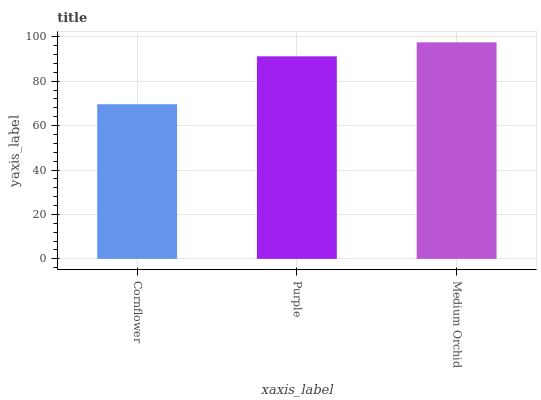Is Purple the minimum?
Answer yes or no. No. Is Purple the maximum?
Answer yes or no. No. Is Purple greater than Cornflower?
Answer yes or no. Yes. Is Cornflower less than Purple?
Answer yes or no. Yes. Is Cornflower greater than Purple?
Answer yes or no. No. Is Purple less than Cornflower?
Answer yes or no. No. Is Purple the high median?
Answer yes or no. Yes. Is Purple the low median?
Answer yes or no. Yes. Is Cornflower the high median?
Answer yes or no. No. Is Cornflower the low median?
Answer yes or no. No. 